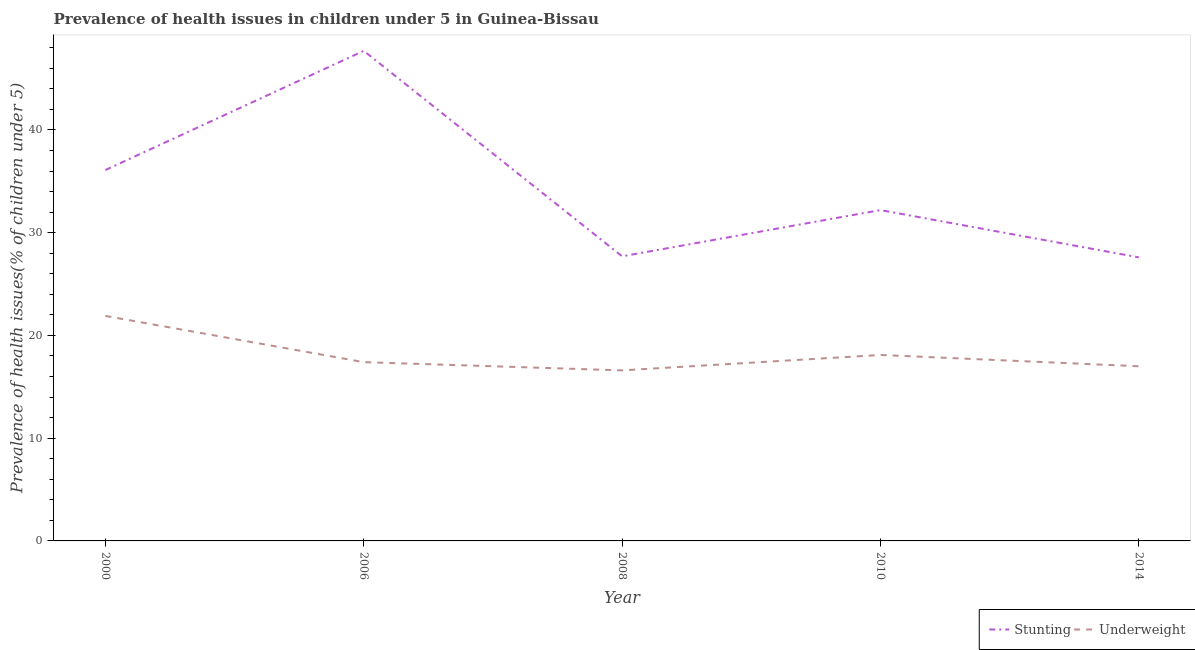How many different coloured lines are there?
Ensure brevity in your answer.  2. Is the number of lines equal to the number of legend labels?
Your answer should be very brief. Yes. What is the percentage of stunted children in 2010?
Ensure brevity in your answer.  32.2. Across all years, what is the maximum percentage of underweight children?
Provide a short and direct response. 21.9. Across all years, what is the minimum percentage of underweight children?
Your response must be concise. 16.6. In which year was the percentage of underweight children minimum?
Offer a terse response. 2008. What is the total percentage of underweight children in the graph?
Provide a short and direct response. 91. What is the difference between the percentage of stunted children in 2008 and that in 2010?
Keep it short and to the point. -4.5. What is the difference between the percentage of underweight children in 2006 and the percentage of stunted children in 2014?
Provide a short and direct response. -10.2. What is the average percentage of underweight children per year?
Your answer should be compact. 18.2. In the year 2000, what is the difference between the percentage of underweight children and percentage of stunted children?
Offer a very short reply. -14.2. What is the ratio of the percentage of underweight children in 2008 to that in 2010?
Your answer should be very brief. 0.92. Is the percentage of stunted children in 2008 less than that in 2014?
Offer a terse response. No. What is the difference between the highest and the second highest percentage of stunted children?
Your response must be concise. 11.6. What is the difference between the highest and the lowest percentage of stunted children?
Offer a very short reply. 20.1. In how many years, is the percentage of stunted children greater than the average percentage of stunted children taken over all years?
Your answer should be very brief. 2. Is the percentage of stunted children strictly greater than the percentage of underweight children over the years?
Provide a succinct answer. Yes. Is the percentage of underweight children strictly less than the percentage of stunted children over the years?
Ensure brevity in your answer.  Yes. How many lines are there?
Offer a terse response. 2. What is the difference between two consecutive major ticks on the Y-axis?
Provide a short and direct response. 10. Does the graph contain any zero values?
Provide a short and direct response. No. Where does the legend appear in the graph?
Keep it short and to the point. Bottom right. What is the title of the graph?
Your answer should be very brief. Prevalence of health issues in children under 5 in Guinea-Bissau. Does "Male labor force" appear as one of the legend labels in the graph?
Provide a succinct answer. No. What is the label or title of the Y-axis?
Your answer should be very brief. Prevalence of health issues(% of children under 5). What is the Prevalence of health issues(% of children under 5) of Stunting in 2000?
Make the answer very short. 36.1. What is the Prevalence of health issues(% of children under 5) of Underweight in 2000?
Ensure brevity in your answer.  21.9. What is the Prevalence of health issues(% of children under 5) in Stunting in 2006?
Provide a short and direct response. 47.7. What is the Prevalence of health issues(% of children under 5) in Underweight in 2006?
Keep it short and to the point. 17.4. What is the Prevalence of health issues(% of children under 5) in Stunting in 2008?
Your answer should be compact. 27.7. What is the Prevalence of health issues(% of children under 5) in Underweight in 2008?
Keep it short and to the point. 16.6. What is the Prevalence of health issues(% of children under 5) in Stunting in 2010?
Keep it short and to the point. 32.2. What is the Prevalence of health issues(% of children under 5) of Underweight in 2010?
Give a very brief answer. 18.1. What is the Prevalence of health issues(% of children under 5) of Stunting in 2014?
Offer a very short reply. 27.6. What is the Prevalence of health issues(% of children under 5) in Underweight in 2014?
Give a very brief answer. 17. Across all years, what is the maximum Prevalence of health issues(% of children under 5) of Stunting?
Ensure brevity in your answer.  47.7. Across all years, what is the maximum Prevalence of health issues(% of children under 5) in Underweight?
Ensure brevity in your answer.  21.9. Across all years, what is the minimum Prevalence of health issues(% of children under 5) of Stunting?
Ensure brevity in your answer.  27.6. Across all years, what is the minimum Prevalence of health issues(% of children under 5) of Underweight?
Give a very brief answer. 16.6. What is the total Prevalence of health issues(% of children under 5) in Stunting in the graph?
Provide a succinct answer. 171.3. What is the total Prevalence of health issues(% of children under 5) in Underweight in the graph?
Keep it short and to the point. 91. What is the difference between the Prevalence of health issues(% of children under 5) of Underweight in 2000 and that in 2006?
Your answer should be very brief. 4.5. What is the difference between the Prevalence of health issues(% of children under 5) of Stunting in 2000 and that in 2008?
Offer a terse response. 8.4. What is the difference between the Prevalence of health issues(% of children under 5) of Underweight in 2000 and that in 2008?
Offer a very short reply. 5.3. What is the difference between the Prevalence of health issues(% of children under 5) in Stunting in 2000 and that in 2010?
Ensure brevity in your answer.  3.9. What is the difference between the Prevalence of health issues(% of children under 5) of Stunting in 2000 and that in 2014?
Ensure brevity in your answer.  8.5. What is the difference between the Prevalence of health issues(% of children under 5) of Underweight in 2006 and that in 2008?
Your answer should be compact. 0.8. What is the difference between the Prevalence of health issues(% of children under 5) of Stunting in 2006 and that in 2014?
Your answer should be compact. 20.1. What is the difference between the Prevalence of health issues(% of children under 5) of Underweight in 2008 and that in 2010?
Your answer should be very brief. -1.5. What is the difference between the Prevalence of health issues(% of children under 5) in Stunting in 2008 and that in 2014?
Make the answer very short. 0.1. What is the difference between the Prevalence of health issues(% of children under 5) in Underweight in 2008 and that in 2014?
Ensure brevity in your answer.  -0.4. What is the difference between the Prevalence of health issues(% of children under 5) of Stunting in 2010 and that in 2014?
Your response must be concise. 4.6. What is the difference between the Prevalence of health issues(% of children under 5) of Underweight in 2010 and that in 2014?
Keep it short and to the point. 1.1. What is the difference between the Prevalence of health issues(% of children under 5) in Stunting in 2000 and the Prevalence of health issues(% of children under 5) in Underweight in 2010?
Provide a short and direct response. 18. What is the difference between the Prevalence of health issues(% of children under 5) of Stunting in 2006 and the Prevalence of health issues(% of children under 5) of Underweight in 2008?
Offer a terse response. 31.1. What is the difference between the Prevalence of health issues(% of children under 5) in Stunting in 2006 and the Prevalence of health issues(% of children under 5) in Underweight in 2010?
Provide a succinct answer. 29.6. What is the difference between the Prevalence of health issues(% of children under 5) in Stunting in 2006 and the Prevalence of health issues(% of children under 5) in Underweight in 2014?
Your response must be concise. 30.7. What is the average Prevalence of health issues(% of children under 5) of Stunting per year?
Ensure brevity in your answer.  34.26. What is the average Prevalence of health issues(% of children under 5) of Underweight per year?
Offer a very short reply. 18.2. In the year 2000, what is the difference between the Prevalence of health issues(% of children under 5) of Stunting and Prevalence of health issues(% of children under 5) of Underweight?
Make the answer very short. 14.2. In the year 2006, what is the difference between the Prevalence of health issues(% of children under 5) in Stunting and Prevalence of health issues(% of children under 5) in Underweight?
Make the answer very short. 30.3. In the year 2008, what is the difference between the Prevalence of health issues(% of children under 5) in Stunting and Prevalence of health issues(% of children under 5) in Underweight?
Make the answer very short. 11.1. In the year 2010, what is the difference between the Prevalence of health issues(% of children under 5) in Stunting and Prevalence of health issues(% of children under 5) in Underweight?
Offer a very short reply. 14.1. What is the ratio of the Prevalence of health issues(% of children under 5) of Stunting in 2000 to that in 2006?
Keep it short and to the point. 0.76. What is the ratio of the Prevalence of health issues(% of children under 5) in Underweight in 2000 to that in 2006?
Offer a very short reply. 1.26. What is the ratio of the Prevalence of health issues(% of children under 5) in Stunting in 2000 to that in 2008?
Your answer should be compact. 1.3. What is the ratio of the Prevalence of health issues(% of children under 5) of Underweight in 2000 to that in 2008?
Keep it short and to the point. 1.32. What is the ratio of the Prevalence of health issues(% of children under 5) in Stunting in 2000 to that in 2010?
Provide a short and direct response. 1.12. What is the ratio of the Prevalence of health issues(% of children under 5) in Underweight in 2000 to that in 2010?
Ensure brevity in your answer.  1.21. What is the ratio of the Prevalence of health issues(% of children under 5) of Stunting in 2000 to that in 2014?
Give a very brief answer. 1.31. What is the ratio of the Prevalence of health issues(% of children under 5) in Underweight in 2000 to that in 2014?
Provide a succinct answer. 1.29. What is the ratio of the Prevalence of health issues(% of children under 5) of Stunting in 2006 to that in 2008?
Give a very brief answer. 1.72. What is the ratio of the Prevalence of health issues(% of children under 5) in Underweight in 2006 to that in 2008?
Your answer should be compact. 1.05. What is the ratio of the Prevalence of health issues(% of children under 5) in Stunting in 2006 to that in 2010?
Ensure brevity in your answer.  1.48. What is the ratio of the Prevalence of health issues(% of children under 5) in Underweight in 2006 to that in 2010?
Provide a short and direct response. 0.96. What is the ratio of the Prevalence of health issues(% of children under 5) in Stunting in 2006 to that in 2014?
Offer a terse response. 1.73. What is the ratio of the Prevalence of health issues(% of children under 5) in Underweight in 2006 to that in 2014?
Provide a short and direct response. 1.02. What is the ratio of the Prevalence of health issues(% of children under 5) in Stunting in 2008 to that in 2010?
Make the answer very short. 0.86. What is the ratio of the Prevalence of health issues(% of children under 5) of Underweight in 2008 to that in 2010?
Give a very brief answer. 0.92. What is the ratio of the Prevalence of health issues(% of children under 5) in Stunting in 2008 to that in 2014?
Offer a terse response. 1. What is the ratio of the Prevalence of health issues(% of children under 5) of Underweight in 2008 to that in 2014?
Offer a terse response. 0.98. What is the ratio of the Prevalence of health issues(% of children under 5) in Underweight in 2010 to that in 2014?
Give a very brief answer. 1.06. What is the difference between the highest and the second highest Prevalence of health issues(% of children under 5) in Stunting?
Keep it short and to the point. 11.6. What is the difference between the highest and the second highest Prevalence of health issues(% of children under 5) in Underweight?
Your response must be concise. 3.8. What is the difference between the highest and the lowest Prevalence of health issues(% of children under 5) of Stunting?
Offer a very short reply. 20.1. What is the difference between the highest and the lowest Prevalence of health issues(% of children under 5) of Underweight?
Provide a short and direct response. 5.3. 